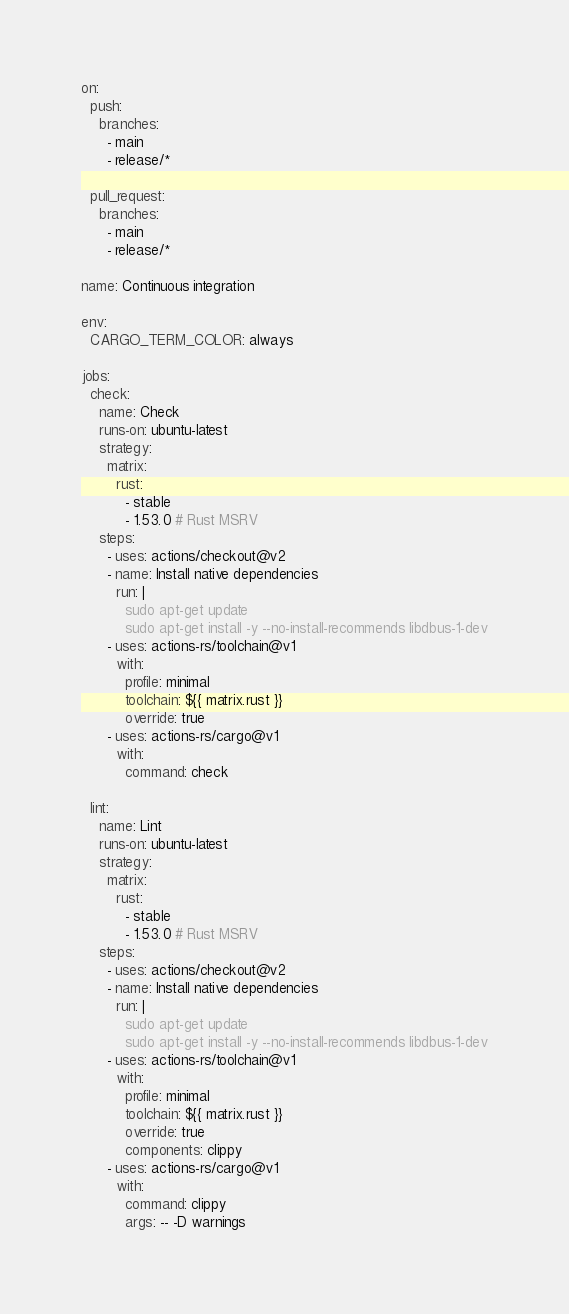<code> <loc_0><loc_0><loc_500><loc_500><_YAML_>on:
  push:
    branches:
      - main
      - release/*

  pull_request:
    branches:
      - main
      - release/*

name: Continuous integration

env:
  CARGO_TERM_COLOR: always

jobs:
  check:
    name: Check
    runs-on: ubuntu-latest
    strategy:
      matrix:
        rust:
          - stable
          - 1.53.0 # Rust MSRV
    steps:
      - uses: actions/checkout@v2
      - name: Install native dependencies
        run: |
          sudo apt-get update
          sudo apt-get install -y --no-install-recommends libdbus-1-dev
      - uses: actions-rs/toolchain@v1
        with:
          profile: minimal
          toolchain: ${{ matrix.rust }}
          override: true
      - uses: actions-rs/cargo@v1
        with:
          command: check

  lint:
    name: Lint
    runs-on: ubuntu-latest
    strategy:
      matrix:
        rust:
          - stable
          - 1.53.0 # Rust MSRV
    steps:
      - uses: actions/checkout@v2
      - name: Install native dependencies
        run: |
          sudo apt-get update
          sudo apt-get install -y --no-install-recommends libdbus-1-dev
      - uses: actions-rs/toolchain@v1
        with:
          profile: minimal
          toolchain: ${{ matrix.rust }}
          override: true
          components: clippy
      - uses: actions-rs/cargo@v1
        with:
          command: clippy
          args: -- -D warnings
</code> 